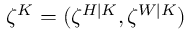Convert formula to latex. <formula><loc_0><loc_0><loc_500><loc_500>\zeta ^ { K } = ( \zeta ^ { H | K } , \zeta ^ { W | K } )</formula> 